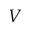Convert formula to latex. <formula><loc_0><loc_0><loc_500><loc_500>V</formula> 